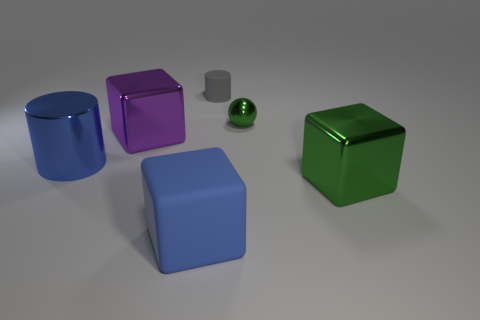Can you categorize the objects in the image by material and shape? Certainly! The objects can be categorized as follows: two rubber cylinders (blue and gray), one green metal cube, one purple metal cube, and one blue rubber cube. 